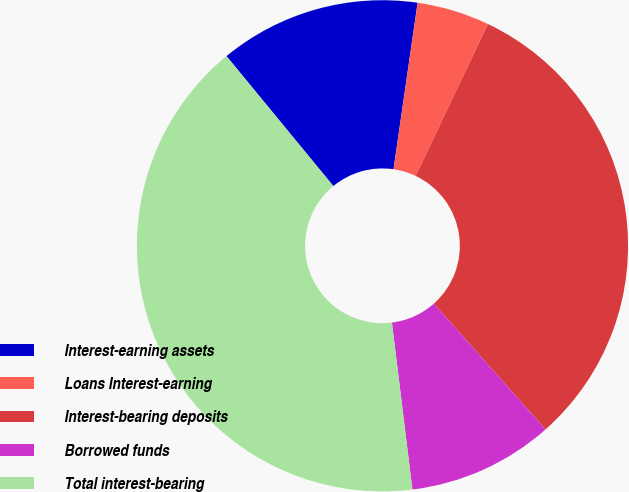Convert chart. <chart><loc_0><loc_0><loc_500><loc_500><pie_chart><fcel>Interest-earning assets<fcel>Loans Interest-earning<fcel>Interest-bearing deposits<fcel>Borrowed funds<fcel>Total interest-bearing<nl><fcel>13.24%<fcel>4.78%<fcel>31.38%<fcel>9.61%<fcel>40.99%<nl></chart> 